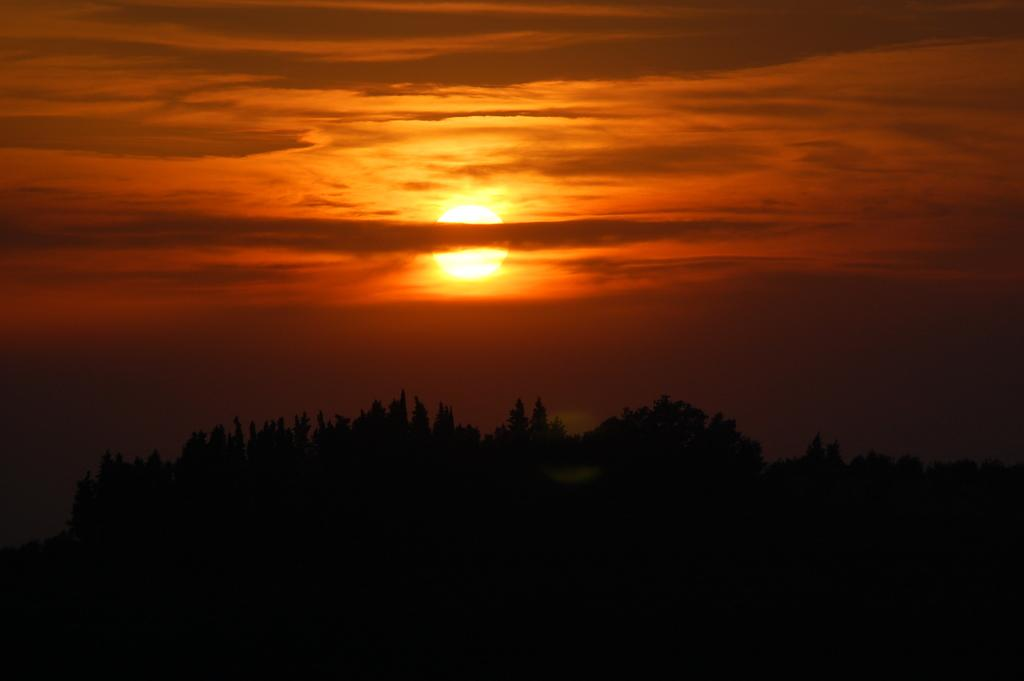What can be seen in the sky in the image? The sky is visible in the image, and clouds are present. Is there any celestial body visible in the image? Yes, the sun is observable in the image. What type of natural vegetation is present in the image? Trees are present in the image. How many fans can be seen in the image? There are no fans present in the image. Is there a slope visible in the image? There is no slope visible in the image. 